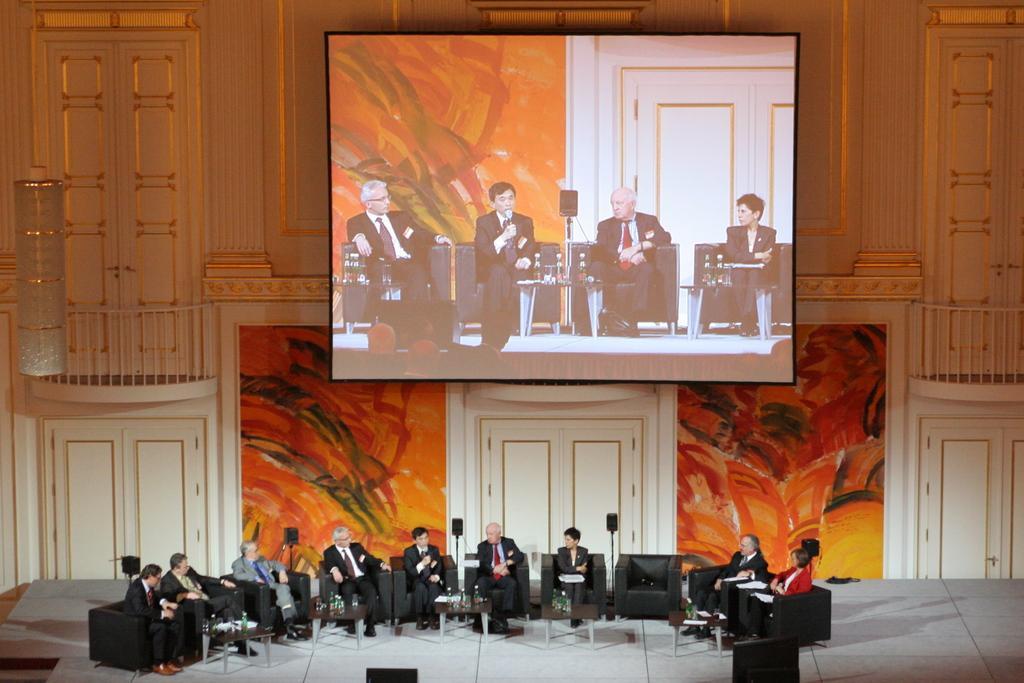In one or two sentences, can you explain what this image depicts? In this Image I can see number of people are sitting on chairs. I can also see all of them are wearing formal dress. Here I can see few tables and on these tables I can see few stuffs. In the background I can see graffiti, a screen and on it I can see few people are sitting. 